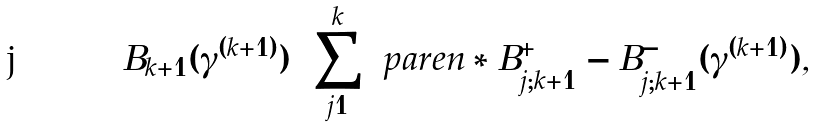Convert formula to latex. <formula><loc_0><loc_0><loc_500><loc_500>B _ { k + 1 } ( \gamma ^ { ( k + 1 ) } ) = \sum _ { j = 1 } ^ { k } \ p a r e n * { B _ { j ; k + 1 } ^ { + } - B _ { j ; k + 1 } ^ { - } } ( \gamma ^ { ( k + 1 ) } ) ,</formula> 